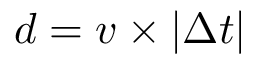<formula> <loc_0><loc_0><loc_500><loc_500>d = v \times | \Delta t |</formula> 